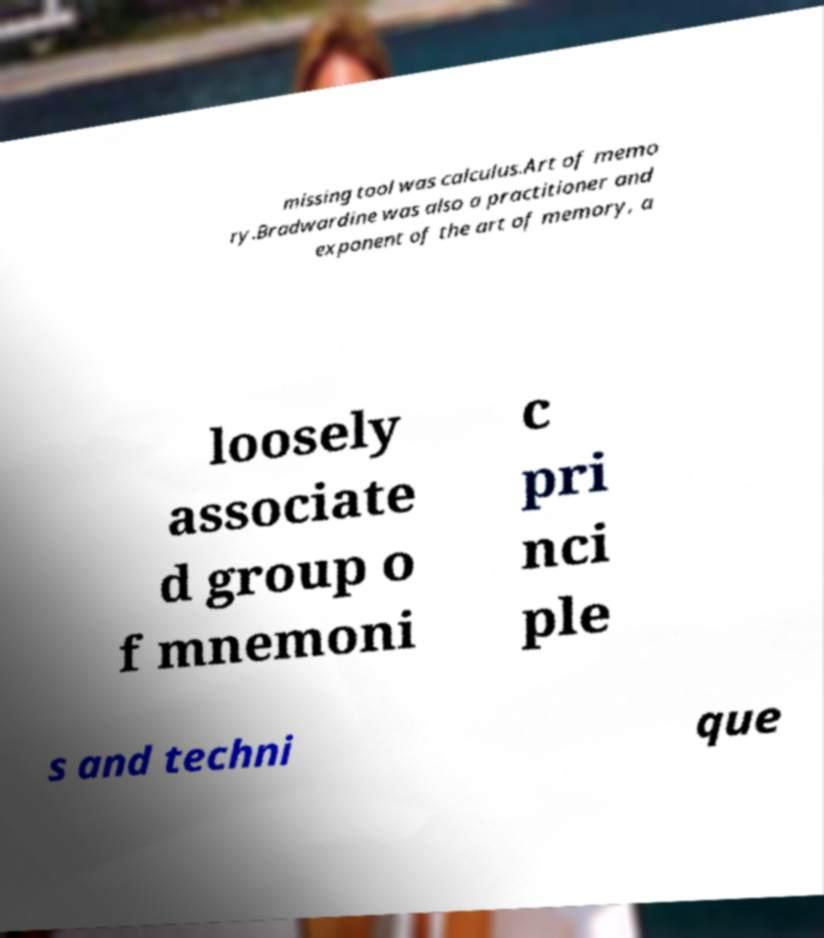Could you extract and type out the text from this image? missing tool was calculus.Art of memo ry.Bradwardine was also a practitioner and exponent of the art of memory, a loosely associate d group o f mnemoni c pri nci ple s and techni que 